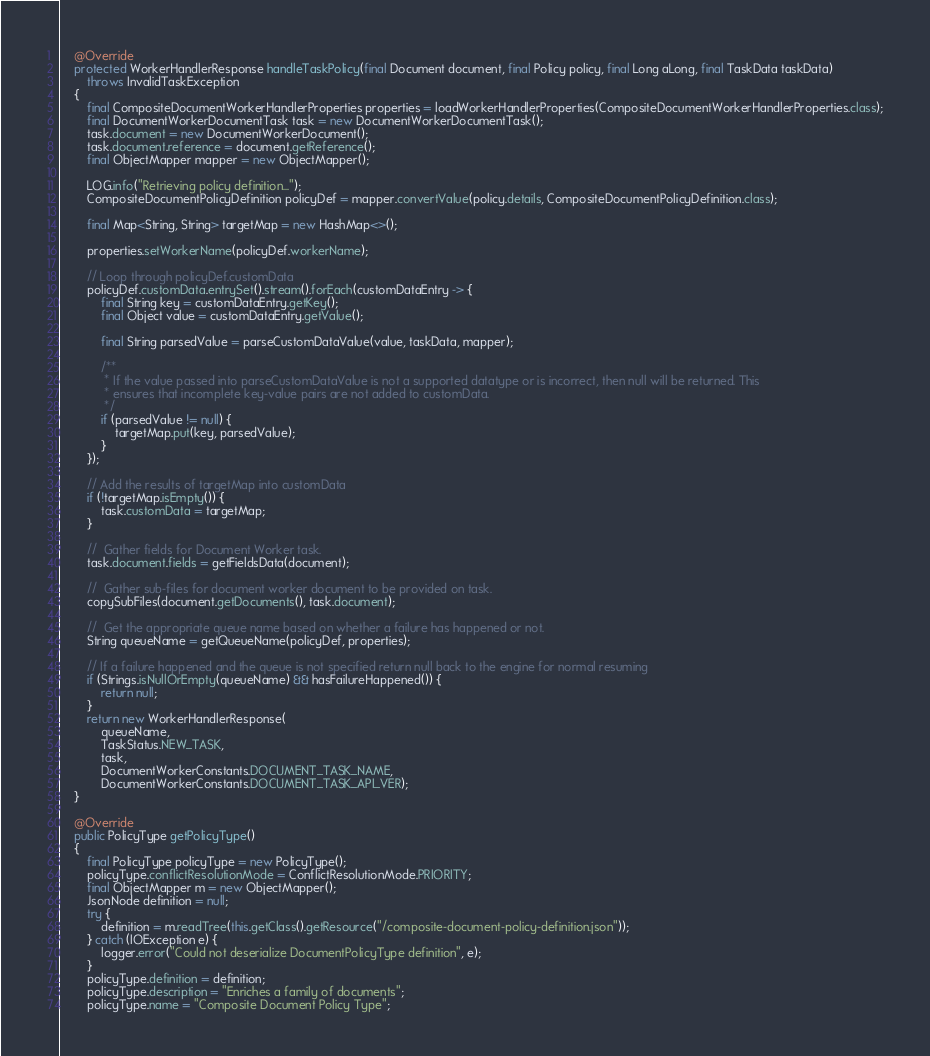<code> <loc_0><loc_0><loc_500><loc_500><_Java_>    @Override
    protected WorkerHandlerResponse handleTaskPolicy(final Document document, final Policy policy, final Long aLong, final TaskData taskData)
        throws InvalidTaskException
    {
        final CompositeDocumentWorkerHandlerProperties properties = loadWorkerHandlerProperties(CompositeDocumentWorkerHandlerProperties.class);
        final DocumentWorkerDocumentTask task = new DocumentWorkerDocumentTask();
        task.document = new DocumentWorkerDocument();
        task.document.reference = document.getReference();
        final ObjectMapper mapper = new ObjectMapper();

        LOG.info("Retrieving policy definition...");
        CompositeDocumentPolicyDefinition policyDef = mapper.convertValue(policy.details, CompositeDocumentPolicyDefinition.class);

        final Map<String, String> targetMap = new HashMap<>();

        properties.setWorkerName(policyDef.workerName);

        // Loop through policyDef.customData
        policyDef.customData.entrySet().stream().forEach(customDataEntry -> {
            final String key = customDataEntry.getKey();
            final Object value = customDataEntry.getValue();

            final String parsedValue = parseCustomDataValue(value, taskData, mapper);

            /**
             * If the value passed into parseCustomDataValue is not a supported datatype or is incorrect, then null will be returned. This
             * ensures that incomplete key-value pairs are not added to customData.
             */
            if (parsedValue != null) {
                targetMap.put(key, parsedValue);
            }
        });

        // Add the results of targetMap into customData
        if (!targetMap.isEmpty()) {
            task.customData = targetMap;
        }

        //  Gather fields for Document Worker task.
        task.document.fields = getFieldsData(document);

        //  Gather sub-files for document worker document to be provided on task.
        copySubFiles(document.getDocuments(), task.document);

        //  Get the appropriate queue name based on whether a failure has happened or not.
        String queueName = getQueueName(policyDef, properties);

        // If a failure happened and the queue is not specified return null back to the engine for normal resuming
        if (Strings.isNullOrEmpty(queueName) && hasFailureHappened()) {
            return null;
        }
        return new WorkerHandlerResponse(
            queueName,
            TaskStatus.NEW_TASK,
            task,
            DocumentWorkerConstants.DOCUMENT_TASK_NAME,
            DocumentWorkerConstants.DOCUMENT_TASK_API_VER);
    }

    @Override
    public PolicyType getPolicyType()
    {
        final PolicyType policyType = new PolicyType();
        policyType.conflictResolutionMode = ConflictResolutionMode.PRIORITY;
        final ObjectMapper m = new ObjectMapper();
        JsonNode definition = null;
        try {
            definition = m.readTree(this.getClass().getResource("/composite-document-policy-definition.json"));
        } catch (IOException e) {
            logger.error("Could not deserialize DocumentPolicyType definition", e);
        }
        policyType.definition = definition;
        policyType.description = "Enriches a family of documents";
        policyType.name = "Composite Document Policy Type";</code> 